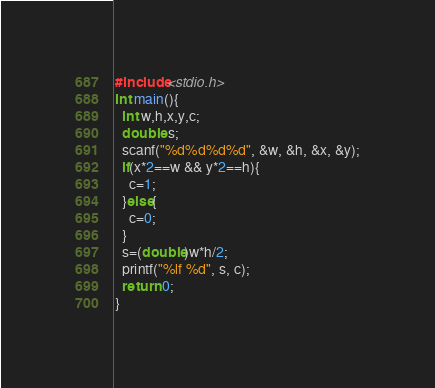<code> <loc_0><loc_0><loc_500><loc_500><_C_>#include<stdio.h>
int main(){
  int w,h,x,y,c;
  double s;
  scanf("%d%d%d%d", &w, &h, &x, &y);
  if(x*2==w && y*2==h){
    c=1;
  }else{
    c=0;
  }
  s=(double)w*h/2;
  printf("%lf %d", s, c);
  return 0;
}</code> 